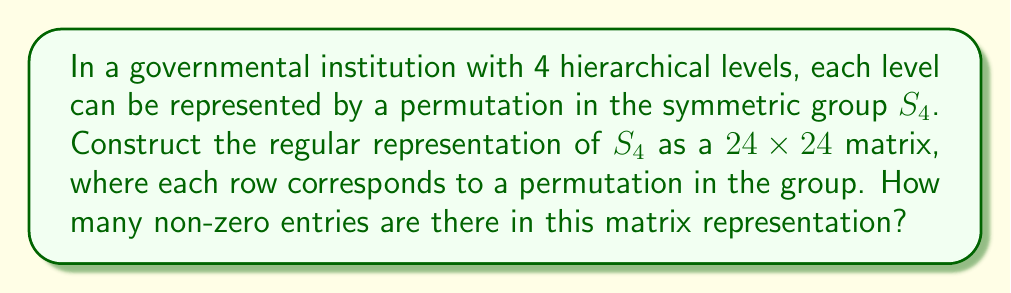What is the answer to this math problem? Let's approach this step-by-step:

1) The symmetric group $S_4$ has 4! = 24 elements (permutations).

2) The regular representation of a group G is a representation where the group acts on itself by left multiplication. It is represented by permutation matrices of size |G| x |G|.

3) In this case, we'll have a 24x24 matrix, where each row and column corresponds to an element of $S_4$.

4) For each element $g \in S_4$, we create a matrix $\rho(g)$ where:

   $\rho(g)_{ij} = \begin{cases} 
   1 & \text{if } gh_j = h_i \\
   0 & \text{otherwise}
   \end{cases}$

   where $h_i$ and $h_j$ are elements of $S_4$.

5) In each row of $\rho(g)$, there will be exactly one 1 and the rest will be 0's. This is because left multiplication by $g$ is a bijection on $S_4$.

6) Since there are 24 rows, and each row has exactly one 1, the total number of non-zero entries in the matrix is 24.

This representation captures the organizational hierarchy by showing how each permutation (representing a level in the hierarchy) acts on all possible arrangements of the four levels.
Answer: 24 